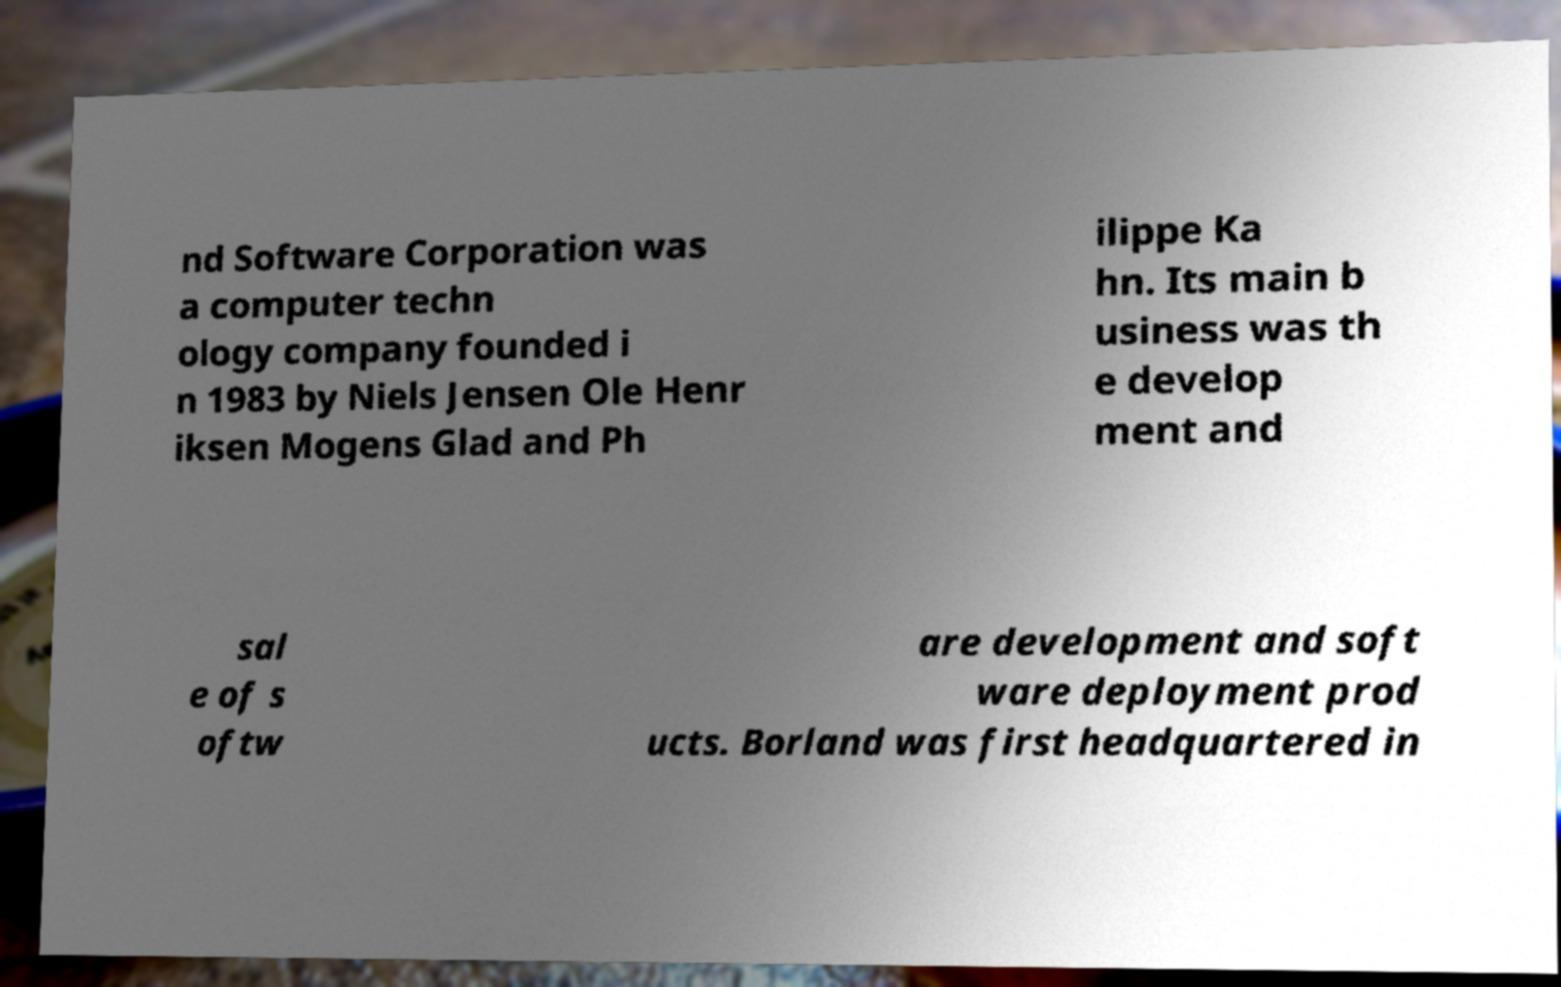There's text embedded in this image that I need extracted. Can you transcribe it verbatim? nd Software Corporation was a computer techn ology company founded i n 1983 by Niels Jensen Ole Henr iksen Mogens Glad and Ph ilippe Ka hn. Its main b usiness was th e develop ment and sal e of s oftw are development and soft ware deployment prod ucts. Borland was first headquartered in 